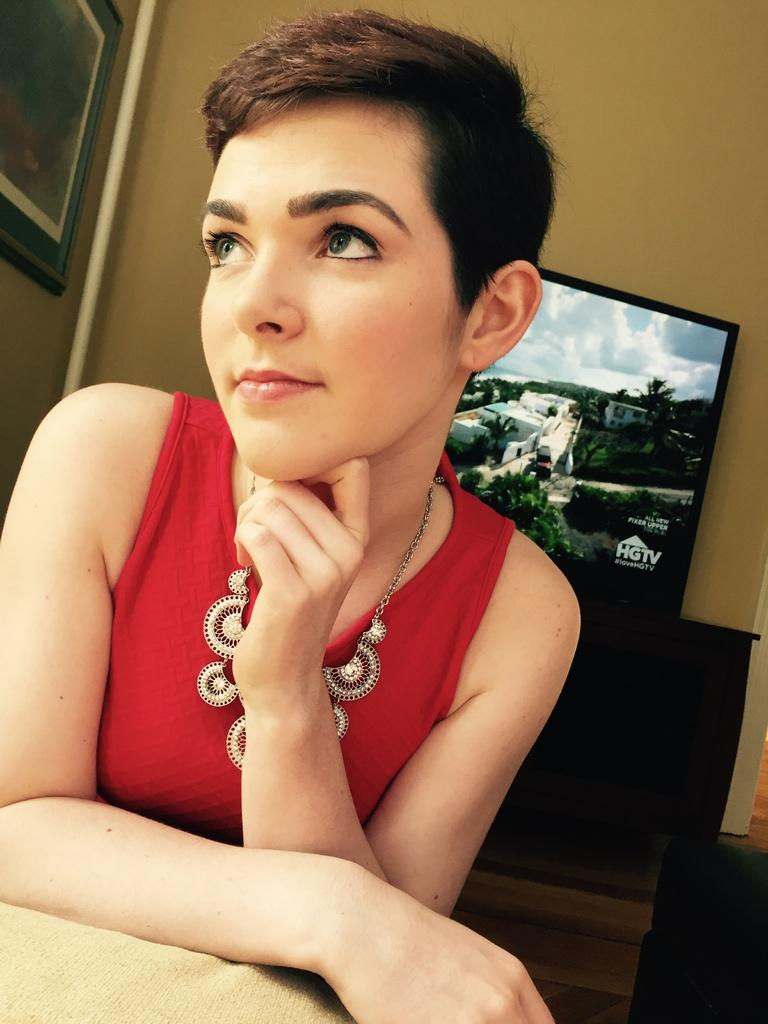Who is present in the image? There is a woman in the image. What can be seen behind the woman? There is a floor, a wall, a television, and a frame in the background of the image. Can you describe the other objects in the background of the image? There are other objects in the background of the image, but their specific details are not mentioned in the provided facts. What type of insurance does the woman have in the image? There is no information about insurance in the image. The image only shows a woman and some background elements. 